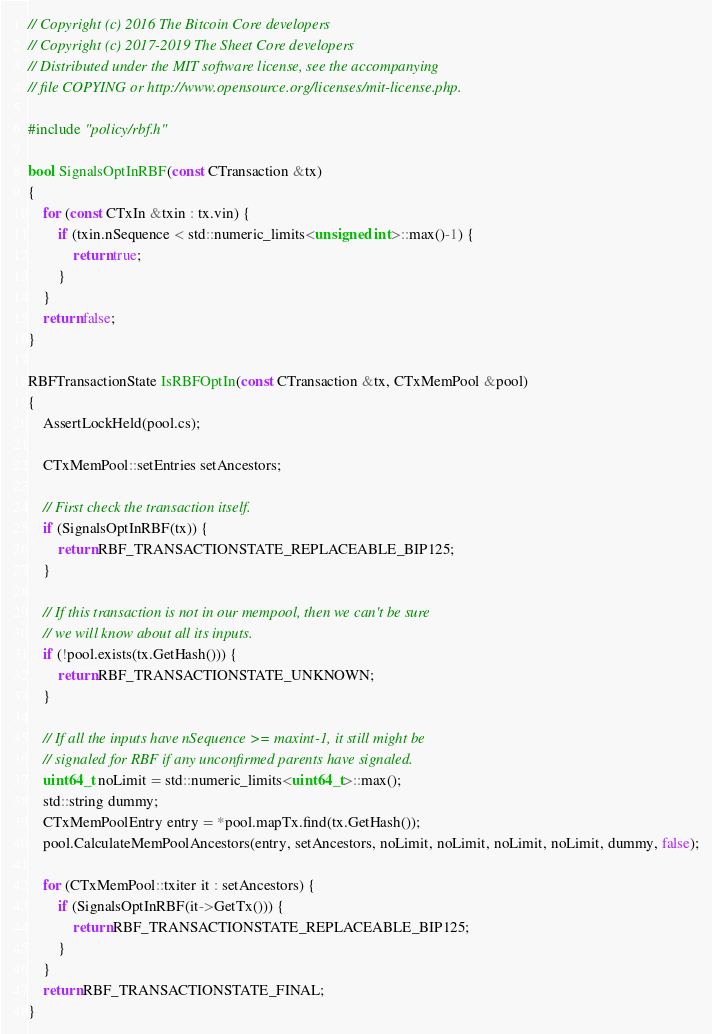<code> <loc_0><loc_0><loc_500><loc_500><_C++_>// Copyright (c) 2016 The Bitcoin Core developers
// Copyright (c) 2017-2019 The Sheet Core developers
// Distributed under the MIT software license, see the accompanying
// file COPYING or http://www.opensource.org/licenses/mit-license.php.

#include "policy/rbf.h"

bool SignalsOptInRBF(const CTransaction &tx)
{
    for (const CTxIn &txin : tx.vin) {
        if (txin.nSequence < std::numeric_limits<unsigned int>::max()-1) {
            return true;
        }
    }
    return false;
}

RBFTransactionState IsRBFOptIn(const CTransaction &tx, CTxMemPool &pool)
{
    AssertLockHeld(pool.cs);

    CTxMemPool::setEntries setAncestors;

    // First check the transaction itself.
    if (SignalsOptInRBF(tx)) {
        return RBF_TRANSACTIONSTATE_REPLACEABLE_BIP125;
    }

    // If this transaction is not in our mempool, then we can't be sure
    // we will know about all its inputs.
    if (!pool.exists(tx.GetHash())) {
        return RBF_TRANSACTIONSTATE_UNKNOWN;
    }

    // If all the inputs have nSequence >= maxint-1, it still might be
    // signaled for RBF if any unconfirmed parents have signaled.
    uint64_t noLimit = std::numeric_limits<uint64_t>::max();
    std::string dummy;
    CTxMemPoolEntry entry = *pool.mapTx.find(tx.GetHash());
    pool.CalculateMemPoolAncestors(entry, setAncestors, noLimit, noLimit, noLimit, noLimit, dummy, false);

    for (CTxMemPool::txiter it : setAncestors) {
        if (SignalsOptInRBF(it->GetTx())) {
            return RBF_TRANSACTIONSTATE_REPLACEABLE_BIP125;
        }
    }
    return RBF_TRANSACTIONSTATE_FINAL;
}
</code> 